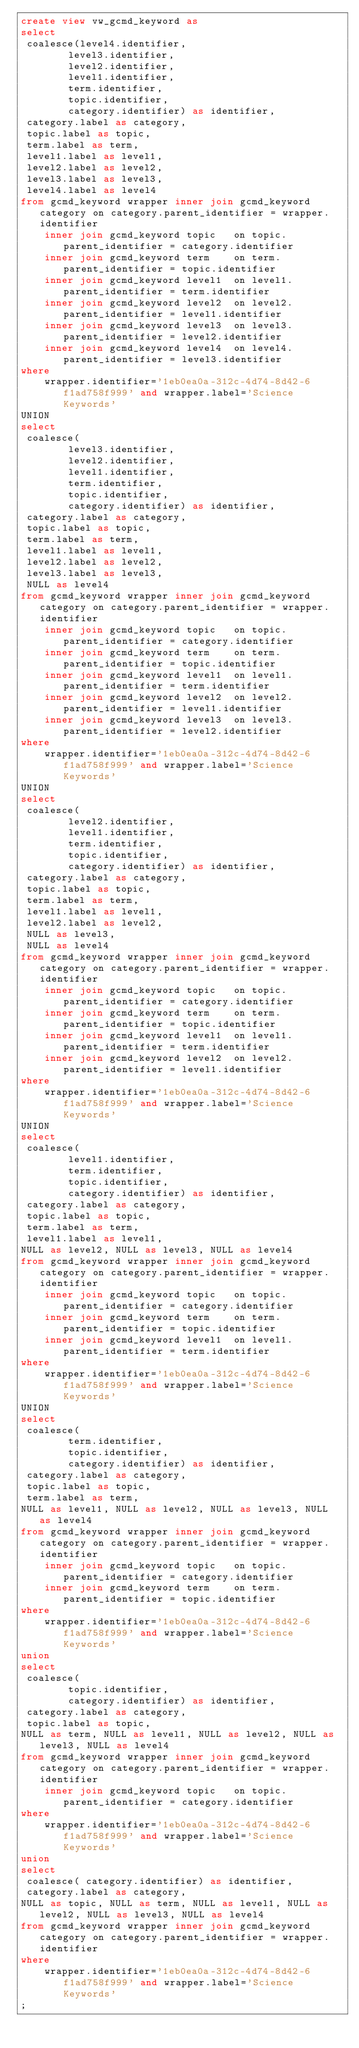Convert code to text. <code><loc_0><loc_0><loc_500><loc_500><_SQL_>create view vw_gcmd_keyword as
select 
 coalesce(level4.identifier,
        level3.identifier,
        level2.identifier,
        level1.identifier,
        term.identifier,
        topic.identifier,
        category.identifier) as identifier,
 category.label as category,
 topic.label as topic,
 term.label as term,
 level1.label as level1,
 level2.label as level2,
 level3.label as level3,
 level4.label as level4
from gcmd_keyword wrapper inner join gcmd_keyword category on category.parent_identifier = wrapper.identifier
    inner join gcmd_keyword topic   on topic.parent_identifier = category.identifier
    inner join gcmd_keyword term    on term.parent_identifier = topic.identifier
    inner join gcmd_keyword level1  on level1.parent_identifier = term.identifier
    inner join gcmd_keyword level2  on level2.parent_identifier = level1.identifier
    inner join gcmd_keyword level3  on level3.parent_identifier = level2.identifier
    inner join gcmd_keyword level4  on level4.parent_identifier = level3.identifier
where
    wrapper.identifier='1eb0ea0a-312c-4d74-8d42-6f1ad758f999' and wrapper.label='Science Keywords'
UNION
select 
 coalesce(
        level3.identifier,
        level2.identifier,
        level1.identifier,
        term.identifier,
        topic.identifier,
        category.identifier) as identifier,
 category.label as category,
 topic.label as topic,
 term.label as term,
 level1.label as level1,
 level2.label as level2,
 level3.label as level3,
 NULL as level4
from gcmd_keyword wrapper inner join gcmd_keyword category on category.parent_identifier = wrapper.identifier
    inner join gcmd_keyword topic   on topic.parent_identifier = category.identifier
    inner join gcmd_keyword term    on term.parent_identifier = topic.identifier
    inner join gcmd_keyword level1  on level1.parent_identifier = term.identifier
    inner join gcmd_keyword level2  on level2.parent_identifier = level1.identifier
    inner join gcmd_keyword level3  on level3.parent_identifier = level2.identifier
where
    wrapper.identifier='1eb0ea0a-312c-4d74-8d42-6f1ad758f999' and wrapper.label='Science Keywords'
UNION
select 
 coalesce(
        level2.identifier,
        level1.identifier,
        term.identifier,
        topic.identifier,
        category.identifier) as identifier,
 category.label as category,
 topic.label as topic,
 term.label as term,
 level1.label as level1,
 level2.label as level2,
 NULL as level3,
 NULL as level4
from gcmd_keyword wrapper inner join gcmd_keyword category on category.parent_identifier = wrapper.identifier
    inner join gcmd_keyword topic   on topic.parent_identifier = category.identifier
    inner join gcmd_keyword term    on term.parent_identifier = topic.identifier
    inner join gcmd_keyword level1  on level1.parent_identifier = term.identifier
    inner join gcmd_keyword level2  on level2.parent_identifier = level1.identifier
where
    wrapper.identifier='1eb0ea0a-312c-4d74-8d42-6f1ad758f999' and wrapper.label='Science Keywords'
UNION
select 
 coalesce(
        level1.identifier,
        term.identifier,
        topic.identifier,
        category.identifier) as identifier,
 category.label as category,
 topic.label as topic,
 term.label as term,
 level1.label as level1,
NULL as level2, NULL as level3, NULL as level4
from gcmd_keyword wrapper inner join gcmd_keyword category on category.parent_identifier = wrapper.identifier
    inner join gcmd_keyword topic   on topic.parent_identifier = category.identifier
    inner join gcmd_keyword term    on term.parent_identifier = topic.identifier
    inner join gcmd_keyword level1  on level1.parent_identifier = term.identifier
where
    wrapper.identifier='1eb0ea0a-312c-4d74-8d42-6f1ad758f999' and wrapper.label='Science Keywords'
UNION
select 
 coalesce(
        term.identifier,
        topic.identifier,
        category.identifier) as identifier,
 category.label as category,
 topic.label as topic,
 term.label as term,
NULL as level1, NULL as level2, NULL as level3, NULL as level4
from gcmd_keyword wrapper inner join gcmd_keyword category on category.parent_identifier = wrapper.identifier
    inner join gcmd_keyword topic   on topic.parent_identifier = category.identifier
    inner join gcmd_keyword term    on term.parent_identifier = topic.identifier
where
    wrapper.identifier='1eb0ea0a-312c-4d74-8d42-6f1ad758f999' and wrapper.label='Science Keywords'
union
select 
 coalesce(
        topic.identifier,
        category.identifier) as identifier,
 category.label as category,
 topic.label as topic,
NULL as term, NULL as level1, NULL as level2, NULL as level3, NULL as level4
from gcmd_keyword wrapper inner join gcmd_keyword category on category.parent_identifier = wrapper.identifier
    inner join gcmd_keyword topic   on topic.parent_identifier = category.identifier
where
    wrapper.identifier='1eb0ea0a-312c-4d74-8d42-6f1ad758f999' and wrapper.label='Science Keywords'
union
select 
 coalesce( category.identifier) as identifier,
 category.label as category,
NULL as topic, NULL as term, NULL as level1, NULL as level2, NULL as level3, NULL as level4
from gcmd_keyword wrapper inner join gcmd_keyword category on category.parent_identifier = wrapper.identifier
where
    wrapper.identifier='1eb0ea0a-312c-4d74-8d42-6f1ad758f999' and wrapper.label='Science Keywords'
;
</code> 